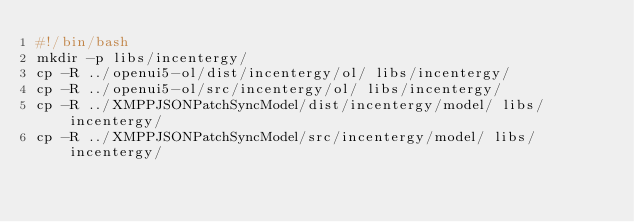<code> <loc_0><loc_0><loc_500><loc_500><_Bash_>#!/bin/bash
mkdir -p libs/incentergy/
cp -R ../openui5-ol/dist/incentergy/ol/ libs/incentergy/
cp -R ../openui5-ol/src/incentergy/ol/ libs/incentergy/
cp -R ../XMPPJSONPatchSyncModel/dist/incentergy/model/ libs/incentergy/
cp -R ../XMPPJSONPatchSyncModel/src/incentergy/model/ libs/incentergy/
</code> 